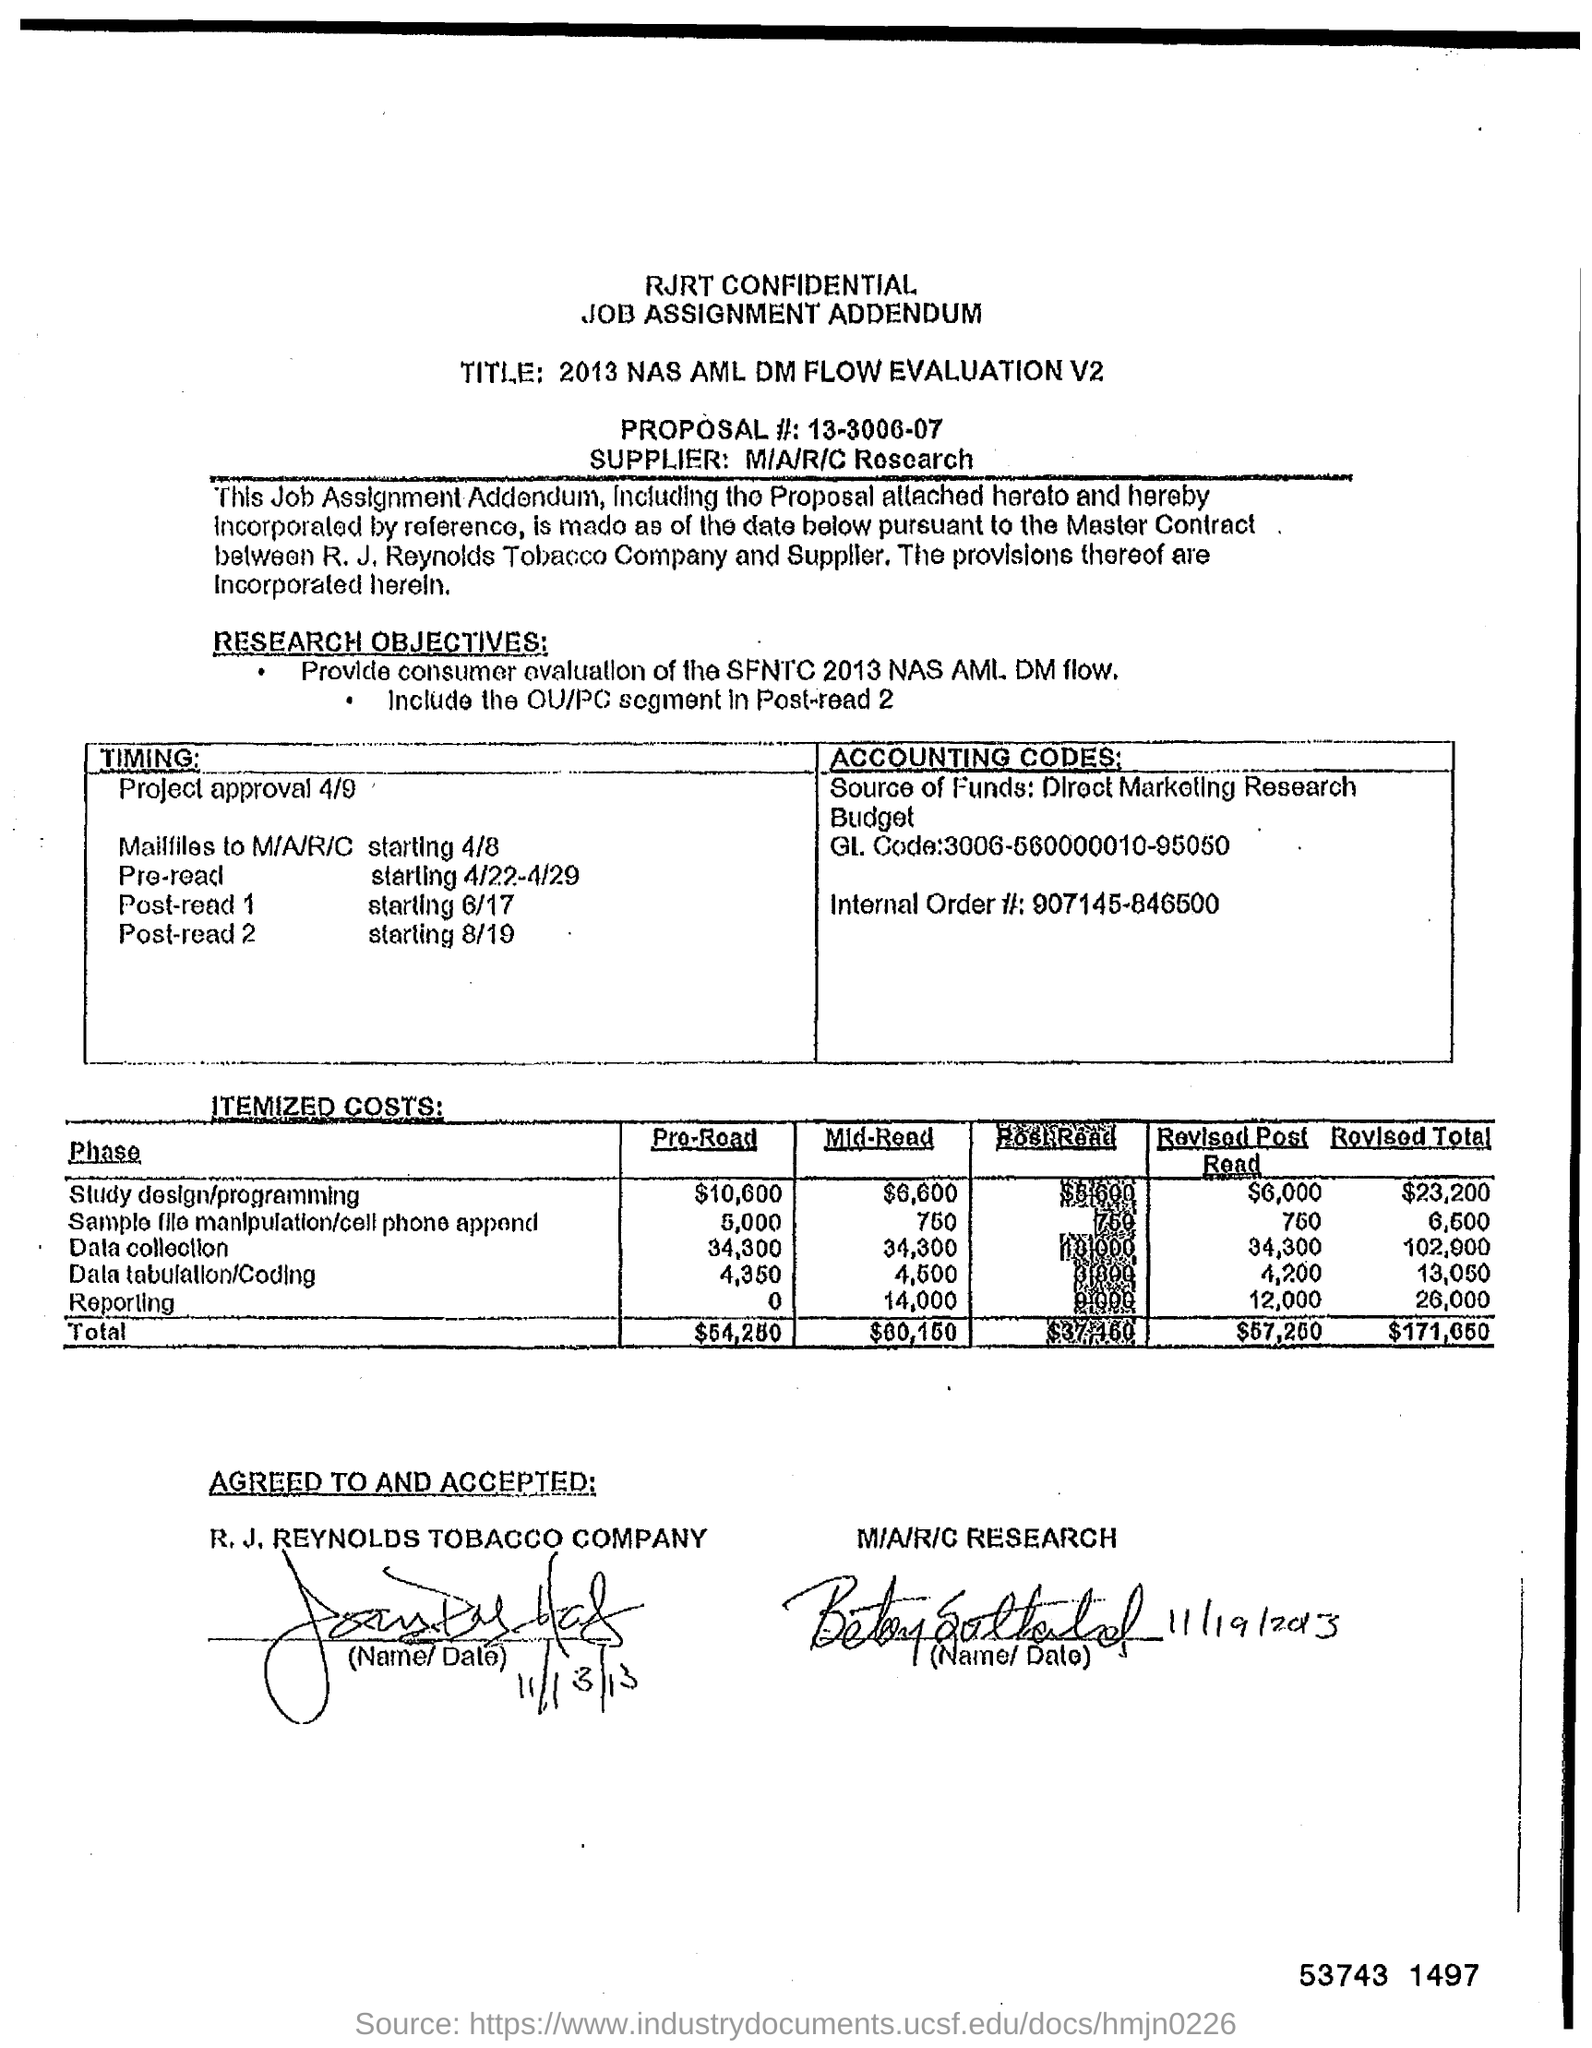Identify some key points in this picture. The revised total for data collection is 102,900. The revised total for reporting is 26,000. The supplier is M/A/R/C Research. 